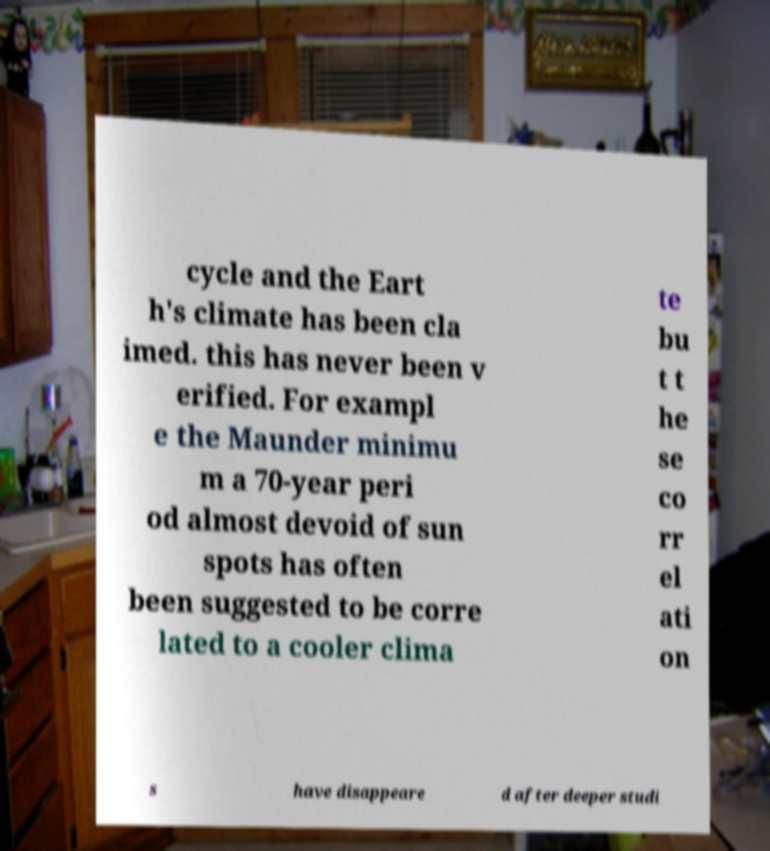Could you assist in decoding the text presented in this image and type it out clearly? cycle and the Eart h's climate has been cla imed. this has never been v erified. For exampl e the Maunder minimu m a 70-year peri od almost devoid of sun spots has often been suggested to be corre lated to a cooler clima te bu t t he se co rr el ati on s have disappeare d after deeper studi 